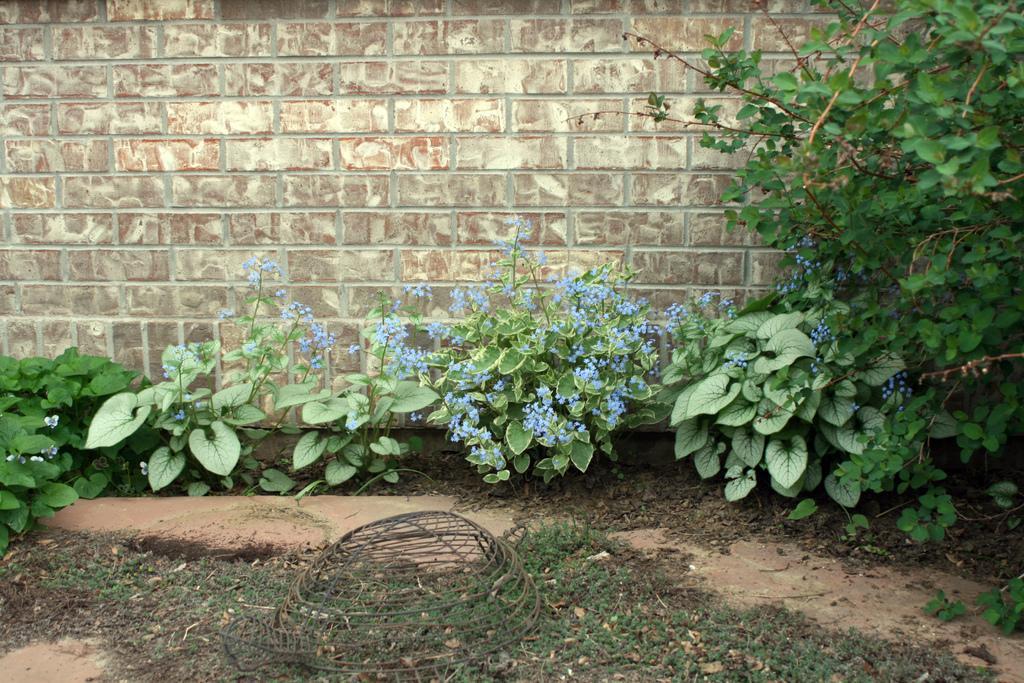Please provide a concise description of this image. In this picture I can see there is grass, there are plants in the backdrop, there are blue color flowers to the plants and there is a brick wall in the backdrop. 